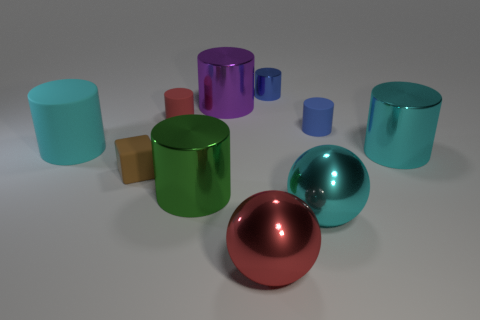Is the small brown block made of the same material as the big purple thing?
Keep it short and to the point. No. How many yellow matte cubes are there?
Your answer should be very brief. 0. There is a big object left of the tiny rubber object that is in front of the big cyan thing to the left of the green cylinder; what color is it?
Your answer should be compact. Cyan. Do the small rubber block and the big rubber cylinder have the same color?
Offer a very short reply. No. How many big objects are right of the brown rubber block and on the left side of the large green object?
Your answer should be very brief. 0. How many metal things are tiny cubes or cyan things?
Keep it short and to the point. 2. What material is the big cyan cylinder behind the cyan cylinder on the right side of the cyan matte cylinder made of?
Your answer should be very brief. Rubber. What shape is the tiny rubber thing that is the same color as the tiny shiny cylinder?
Keep it short and to the point. Cylinder. The red metal thing that is the same size as the purple shiny cylinder is what shape?
Provide a short and direct response. Sphere. Are there fewer tiny brown things than small gray cylinders?
Your answer should be very brief. No. 